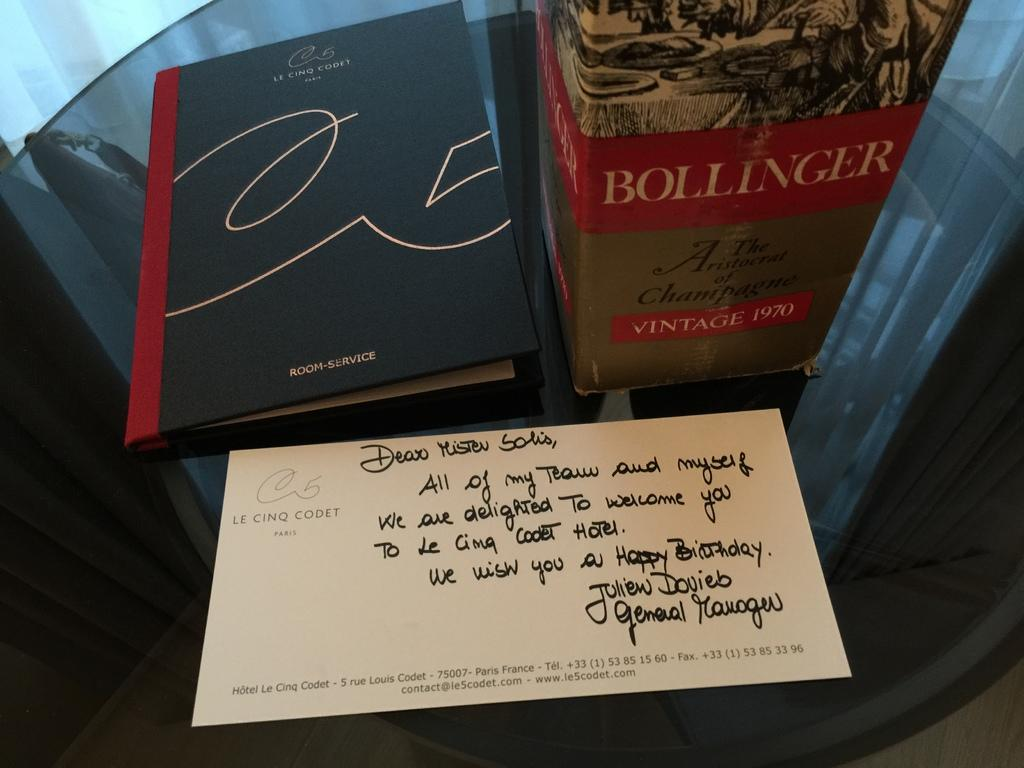<image>
Relay a brief, clear account of the picture shown. Book and a bottle of champagne from Bollinger with a postcard 